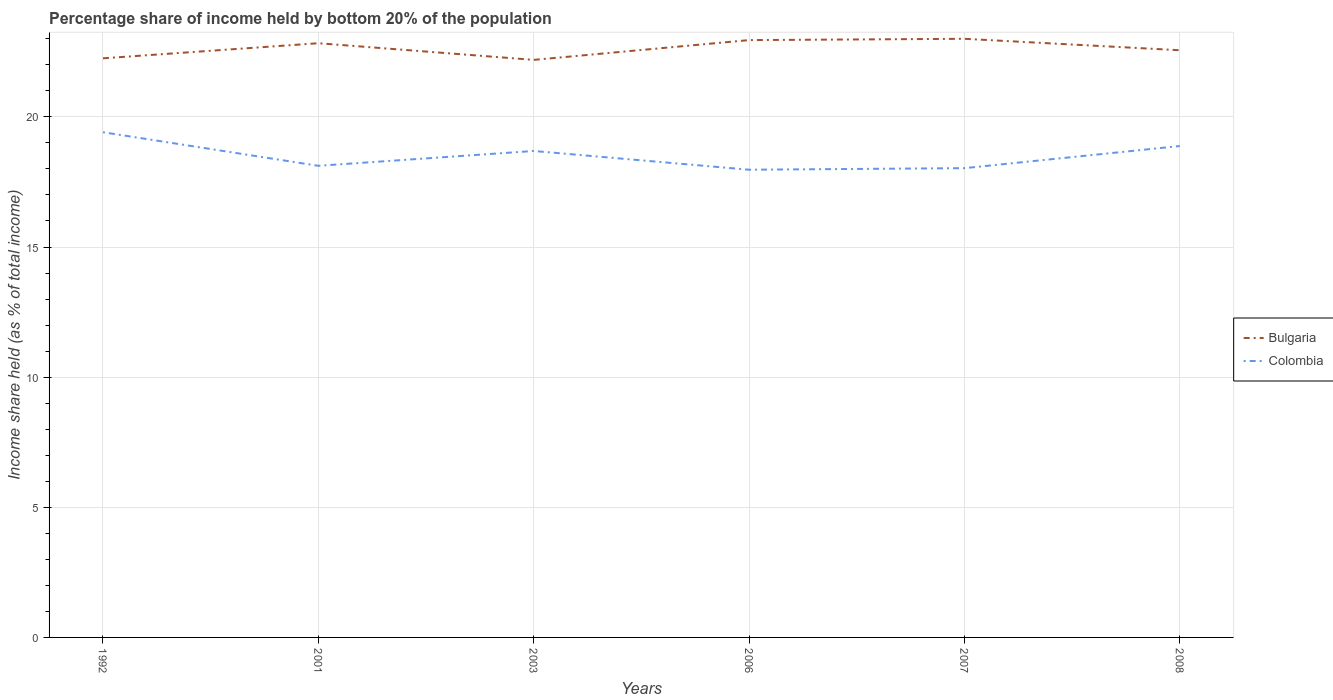Is the number of lines equal to the number of legend labels?
Your response must be concise. Yes. Across all years, what is the maximum share of income held by bottom 20% of the population in Colombia?
Ensure brevity in your answer.  17.97. In which year was the share of income held by bottom 20% of the population in Bulgaria maximum?
Keep it short and to the point. 2003. What is the total share of income held by bottom 20% of the population in Colombia in the graph?
Make the answer very short. -0.85. What is the difference between the highest and the second highest share of income held by bottom 20% of the population in Bulgaria?
Your answer should be very brief. 0.81. Is the share of income held by bottom 20% of the population in Bulgaria strictly greater than the share of income held by bottom 20% of the population in Colombia over the years?
Provide a succinct answer. No. How many lines are there?
Provide a short and direct response. 2. How many years are there in the graph?
Provide a succinct answer. 6. Are the values on the major ticks of Y-axis written in scientific E-notation?
Your response must be concise. No. Does the graph contain any zero values?
Offer a terse response. No. Does the graph contain grids?
Make the answer very short. Yes. What is the title of the graph?
Keep it short and to the point. Percentage share of income held by bottom 20% of the population. What is the label or title of the Y-axis?
Your answer should be compact. Income share held (as % of total income). What is the Income share held (as % of total income) in Bulgaria in 1992?
Your response must be concise. 22.25. What is the Income share held (as % of total income) of Colombia in 1992?
Give a very brief answer. 19.41. What is the Income share held (as % of total income) of Bulgaria in 2001?
Your answer should be very brief. 22.83. What is the Income share held (as % of total income) in Colombia in 2001?
Provide a short and direct response. 18.12. What is the Income share held (as % of total income) in Bulgaria in 2003?
Offer a terse response. 22.19. What is the Income share held (as % of total income) of Colombia in 2003?
Offer a terse response. 18.69. What is the Income share held (as % of total income) of Bulgaria in 2006?
Provide a short and direct response. 22.95. What is the Income share held (as % of total income) in Colombia in 2006?
Offer a very short reply. 17.97. What is the Income share held (as % of total income) in Colombia in 2007?
Your answer should be compact. 18.03. What is the Income share held (as % of total income) in Bulgaria in 2008?
Offer a terse response. 22.56. What is the Income share held (as % of total income) in Colombia in 2008?
Keep it short and to the point. 18.88. Across all years, what is the maximum Income share held (as % of total income) of Bulgaria?
Ensure brevity in your answer.  23. Across all years, what is the maximum Income share held (as % of total income) of Colombia?
Ensure brevity in your answer.  19.41. Across all years, what is the minimum Income share held (as % of total income) in Bulgaria?
Offer a terse response. 22.19. Across all years, what is the minimum Income share held (as % of total income) in Colombia?
Make the answer very short. 17.97. What is the total Income share held (as % of total income) in Bulgaria in the graph?
Your answer should be very brief. 135.78. What is the total Income share held (as % of total income) of Colombia in the graph?
Provide a succinct answer. 111.1. What is the difference between the Income share held (as % of total income) in Bulgaria in 1992 and that in 2001?
Provide a succinct answer. -0.58. What is the difference between the Income share held (as % of total income) of Colombia in 1992 and that in 2001?
Keep it short and to the point. 1.29. What is the difference between the Income share held (as % of total income) of Bulgaria in 1992 and that in 2003?
Make the answer very short. 0.06. What is the difference between the Income share held (as % of total income) in Colombia in 1992 and that in 2003?
Your response must be concise. 0.72. What is the difference between the Income share held (as % of total income) in Bulgaria in 1992 and that in 2006?
Keep it short and to the point. -0.7. What is the difference between the Income share held (as % of total income) in Colombia in 1992 and that in 2006?
Make the answer very short. 1.44. What is the difference between the Income share held (as % of total income) in Bulgaria in 1992 and that in 2007?
Give a very brief answer. -0.75. What is the difference between the Income share held (as % of total income) of Colombia in 1992 and that in 2007?
Ensure brevity in your answer.  1.38. What is the difference between the Income share held (as % of total income) in Bulgaria in 1992 and that in 2008?
Make the answer very short. -0.31. What is the difference between the Income share held (as % of total income) in Colombia in 1992 and that in 2008?
Ensure brevity in your answer.  0.53. What is the difference between the Income share held (as % of total income) of Bulgaria in 2001 and that in 2003?
Your answer should be compact. 0.64. What is the difference between the Income share held (as % of total income) in Colombia in 2001 and that in 2003?
Give a very brief answer. -0.57. What is the difference between the Income share held (as % of total income) in Bulgaria in 2001 and that in 2006?
Make the answer very short. -0.12. What is the difference between the Income share held (as % of total income) of Colombia in 2001 and that in 2006?
Your answer should be compact. 0.15. What is the difference between the Income share held (as % of total income) in Bulgaria in 2001 and that in 2007?
Provide a short and direct response. -0.17. What is the difference between the Income share held (as % of total income) in Colombia in 2001 and that in 2007?
Provide a short and direct response. 0.09. What is the difference between the Income share held (as % of total income) of Bulgaria in 2001 and that in 2008?
Offer a terse response. 0.27. What is the difference between the Income share held (as % of total income) of Colombia in 2001 and that in 2008?
Give a very brief answer. -0.76. What is the difference between the Income share held (as % of total income) in Bulgaria in 2003 and that in 2006?
Your answer should be compact. -0.76. What is the difference between the Income share held (as % of total income) of Colombia in 2003 and that in 2006?
Offer a very short reply. 0.72. What is the difference between the Income share held (as % of total income) of Bulgaria in 2003 and that in 2007?
Your answer should be compact. -0.81. What is the difference between the Income share held (as % of total income) in Colombia in 2003 and that in 2007?
Your response must be concise. 0.66. What is the difference between the Income share held (as % of total income) of Bulgaria in 2003 and that in 2008?
Your answer should be compact. -0.37. What is the difference between the Income share held (as % of total income) in Colombia in 2003 and that in 2008?
Offer a terse response. -0.19. What is the difference between the Income share held (as % of total income) of Bulgaria in 2006 and that in 2007?
Give a very brief answer. -0.05. What is the difference between the Income share held (as % of total income) of Colombia in 2006 and that in 2007?
Your answer should be compact. -0.06. What is the difference between the Income share held (as % of total income) in Bulgaria in 2006 and that in 2008?
Give a very brief answer. 0.39. What is the difference between the Income share held (as % of total income) in Colombia in 2006 and that in 2008?
Provide a short and direct response. -0.91. What is the difference between the Income share held (as % of total income) of Bulgaria in 2007 and that in 2008?
Keep it short and to the point. 0.44. What is the difference between the Income share held (as % of total income) in Colombia in 2007 and that in 2008?
Provide a short and direct response. -0.85. What is the difference between the Income share held (as % of total income) of Bulgaria in 1992 and the Income share held (as % of total income) of Colombia in 2001?
Offer a terse response. 4.13. What is the difference between the Income share held (as % of total income) in Bulgaria in 1992 and the Income share held (as % of total income) in Colombia in 2003?
Offer a terse response. 3.56. What is the difference between the Income share held (as % of total income) in Bulgaria in 1992 and the Income share held (as % of total income) in Colombia in 2006?
Keep it short and to the point. 4.28. What is the difference between the Income share held (as % of total income) of Bulgaria in 1992 and the Income share held (as % of total income) of Colombia in 2007?
Ensure brevity in your answer.  4.22. What is the difference between the Income share held (as % of total income) of Bulgaria in 1992 and the Income share held (as % of total income) of Colombia in 2008?
Your answer should be very brief. 3.37. What is the difference between the Income share held (as % of total income) of Bulgaria in 2001 and the Income share held (as % of total income) of Colombia in 2003?
Give a very brief answer. 4.14. What is the difference between the Income share held (as % of total income) in Bulgaria in 2001 and the Income share held (as % of total income) in Colombia in 2006?
Your response must be concise. 4.86. What is the difference between the Income share held (as % of total income) in Bulgaria in 2001 and the Income share held (as % of total income) in Colombia in 2008?
Ensure brevity in your answer.  3.95. What is the difference between the Income share held (as % of total income) in Bulgaria in 2003 and the Income share held (as % of total income) in Colombia in 2006?
Offer a very short reply. 4.22. What is the difference between the Income share held (as % of total income) of Bulgaria in 2003 and the Income share held (as % of total income) of Colombia in 2007?
Your answer should be compact. 4.16. What is the difference between the Income share held (as % of total income) in Bulgaria in 2003 and the Income share held (as % of total income) in Colombia in 2008?
Give a very brief answer. 3.31. What is the difference between the Income share held (as % of total income) of Bulgaria in 2006 and the Income share held (as % of total income) of Colombia in 2007?
Offer a terse response. 4.92. What is the difference between the Income share held (as % of total income) of Bulgaria in 2006 and the Income share held (as % of total income) of Colombia in 2008?
Your answer should be very brief. 4.07. What is the difference between the Income share held (as % of total income) of Bulgaria in 2007 and the Income share held (as % of total income) of Colombia in 2008?
Your answer should be very brief. 4.12. What is the average Income share held (as % of total income) of Bulgaria per year?
Give a very brief answer. 22.63. What is the average Income share held (as % of total income) in Colombia per year?
Provide a succinct answer. 18.52. In the year 1992, what is the difference between the Income share held (as % of total income) in Bulgaria and Income share held (as % of total income) in Colombia?
Make the answer very short. 2.84. In the year 2001, what is the difference between the Income share held (as % of total income) in Bulgaria and Income share held (as % of total income) in Colombia?
Provide a succinct answer. 4.71. In the year 2003, what is the difference between the Income share held (as % of total income) in Bulgaria and Income share held (as % of total income) in Colombia?
Your answer should be very brief. 3.5. In the year 2006, what is the difference between the Income share held (as % of total income) of Bulgaria and Income share held (as % of total income) of Colombia?
Give a very brief answer. 4.98. In the year 2007, what is the difference between the Income share held (as % of total income) in Bulgaria and Income share held (as % of total income) in Colombia?
Your answer should be very brief. 4.97. In the year 2008, what is the difference between the Income share held (as % of total income) in Bulgaria and Income share held (as % of total income) in Colombia?
Offer a terse response. 3.68. What is the ratio of the Income share held (as % of total income) in Bulgaria in 1992 to that in 2001?
Provide a succinct answer. 0.97. What is the ratio of the Income share held (as % of total income) of Colombia in 1992 to that in 2001?
Your answer should be very brief. 1.07. What is the ratio of the Income share held (as % of total income) of Colombia in 1992 to that in 2003?
Your answer should be compact. 1.04. What is the ratio of the Income share held (as % of total income) in Bulgaria in 1992 to that in 2006?
Ensure brevity in your answer.  0.97. What is the ratio of the Income share held (as % of total income) of Colombia in 1992 to that in 2006?
Give a very brief answer. 1.08. What is the ratio of the Income share held (as % of total income) of Bulgaria in 1992 to that in 2007?
Ensure brevity in your answer.  0.97. What is the ratio of the Income share held (as % of total income) of Colombia in 1992 to that in 2007?
Your response must be concise. 1.08. What is the ratio of the Income share held (as % of total income) of Bulgaria in 1992 to that in 2008?
Ensure brevity in your answer.  0.99. What is the ratio of the Income share held (as % of total income) in Colombia in 1992 to that in 2008?
Offer a terse response. 1.03. What is the ratio of the Income share held (as % of total income) in Bulgaria in 2001 to that in 2003?
Provide a succinct answer. 1.03. What is the ratio of the Income share held (as % of total income) of Colombia in 2001 to that in 2003?
Your answer should be compact. 0.97. What is the ratio of the Income share held (as % of total income) in Bulgaria in 2001 to that in 2006?
Make the answer very short. 0.99. What is the ratio of the Income share held (as % of total income) of Colombia in 2001 to that in 2006?
Give a very brief answer. 1.01. What is the ratio of the Income share held (as % of total income) in Colombia in 2001 to that in 2007?
Give a very brief answer. 1. What is the ratio of the Income share held (as % of total income) of Bulgaria in 2001 to that in 2008?
Provide a short and direct response. 1.01. What is the ratio of the Income share held (as % of total income) in Colombia in 2001 to that in 2008?
Provide a succinct answer. 0.96. What is the ratio of the Income share held (as % of total income) in Bulgaria in 2003 to that in 2006?
Provide a succinct answer. 0.97. What is the ratio of the Income share held (as % of total income) of Colombia in 2003 to that in 2006?
Give a very brief answer. 1.04. What is the ratio of the Income share held (as % of total income) of Bulgaria in 2003 to that in 2007?
Give a very brief answer. 0.96. What is the ratio of the Income share held (as % of total income) in Colombia in 2003 to that in 2007?
Keep it short and to the point. 1.04. What is the ratio of the Income share held (as % of total income) of Bulgaria in 2003 to that in 2008?
Offer a terse response. 0.98. What is the ratio of the Income share held (as % of total income) in Bulgaria in 2006 to that in 2007?
Ensure brevity in your answer.  1. What is the ratio of the Income share held (as % of total income) of Bulgaria in 2006 to that in 2008?
Provide a succinct answer. 1.02. What is the ratio of the Income share held (as % of total income) of Colombia in 2006 to that in 2008?
Your answer should be compact. 0.95. What is the ratio of the Income share held (as % of total income) of Bulgaria in 2007 to that in 2008?
Keep it short and to the point. 1.02. What is the ratio of the Income share held (as % of total income) in Colombia in 2007 to that in 2008?
Provide a succinct answer. 0.95. What is the difference between the highest and the second highest Income share held (as % of total income) of Colombia?
Your response must be concise. 0.53. What is the difference between the highest and the lowest Income share held (as % of total income) in Bulgaria?
Give a very brief answer. 0.81. What is the difference between the highest and the lowest Income share held (as % of total income) of Colombia?
Your response must be concise. 1.44. 